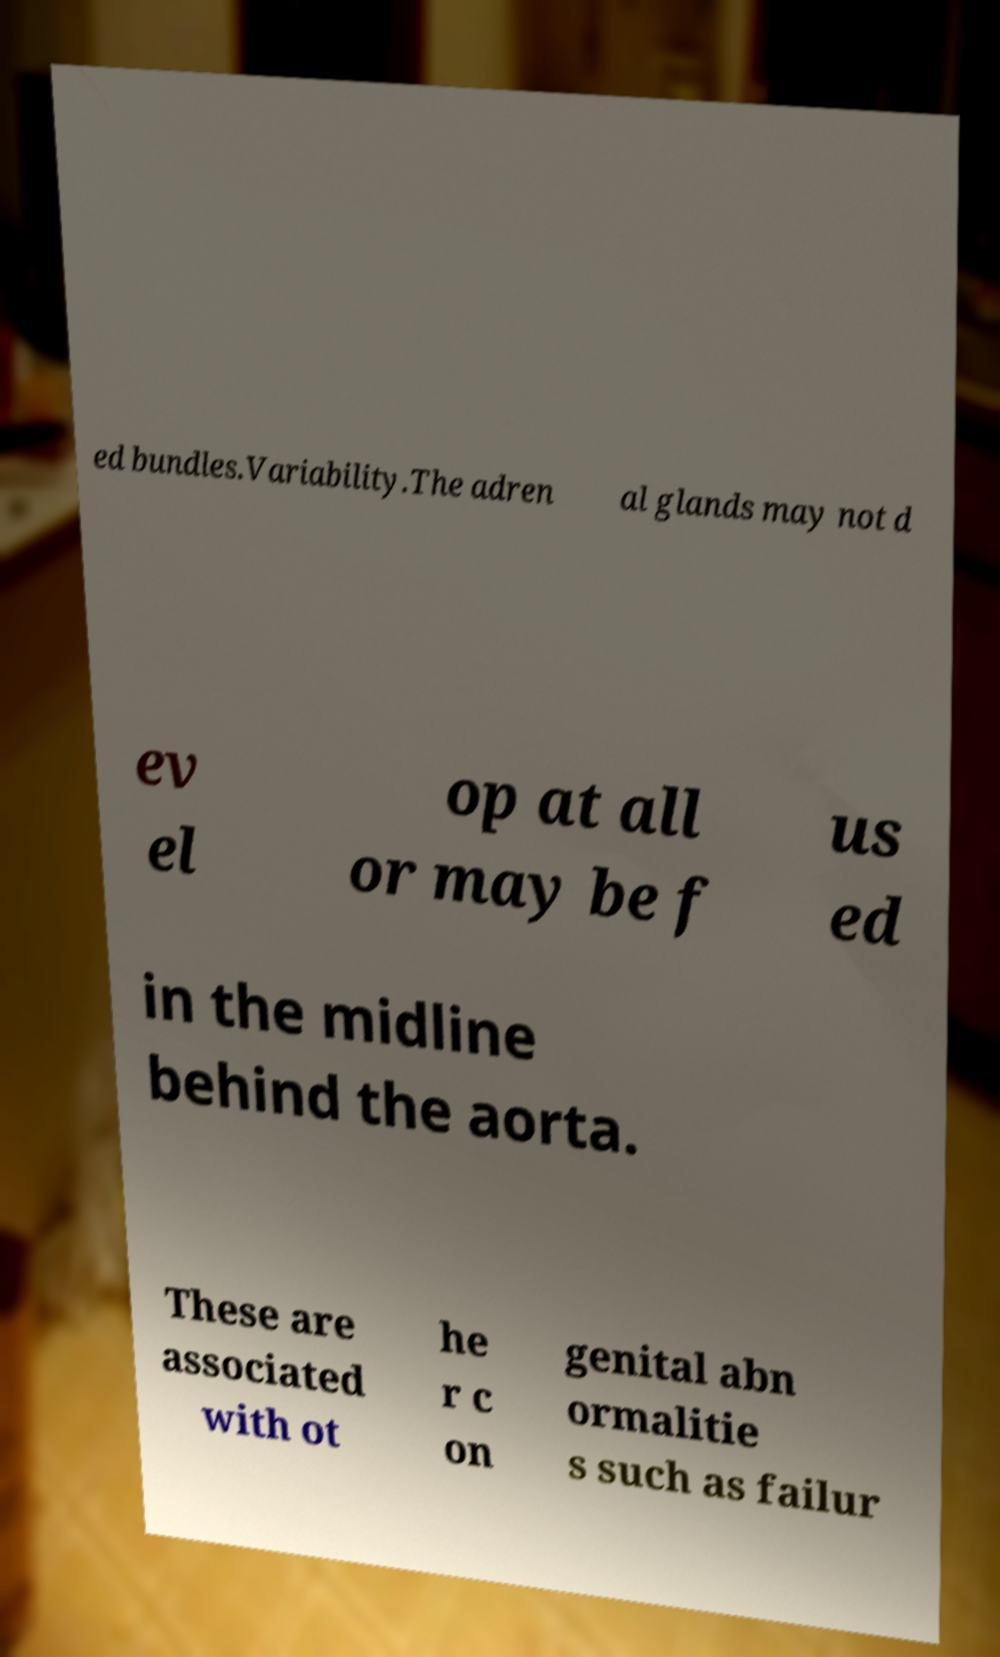For documentation purposes, I need the text within this image transcribed. Could you provide that? ed bundles.Variability.The adren al glands may not d ev el op at all or may be f us ed in the midline behind the aorta. These are associated with ot he r c on genital abn ormalitie s such as failur 